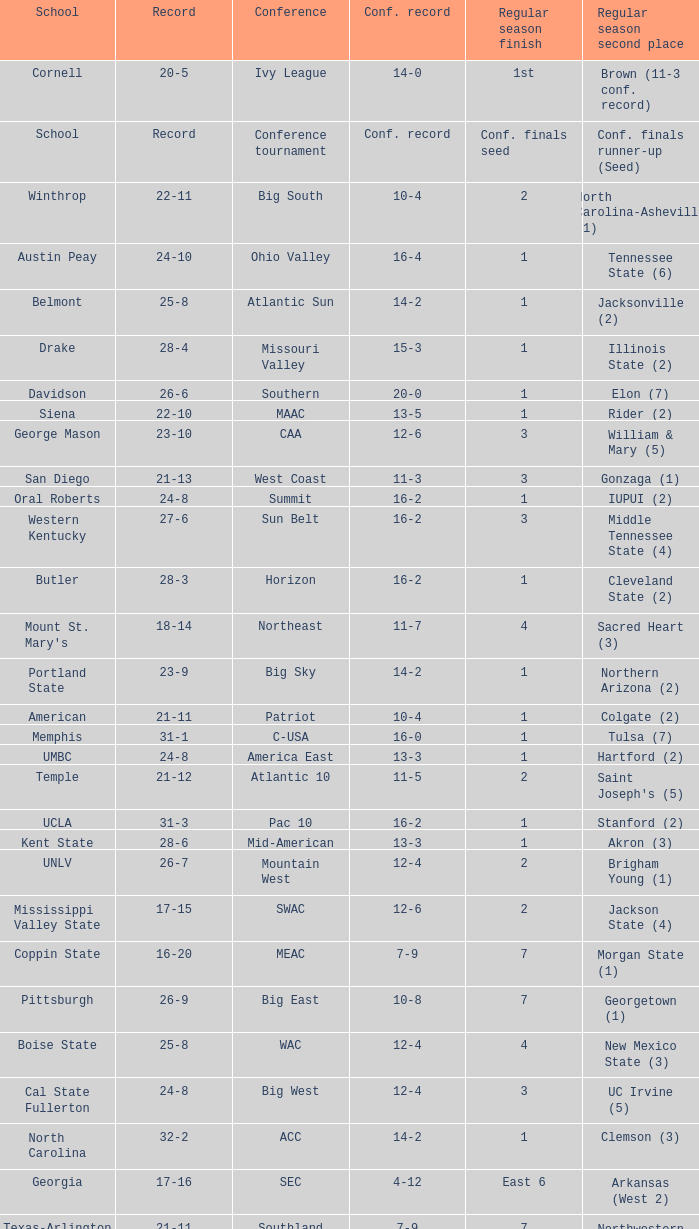Could you help me parse every detail presented in this table? {'header': ['School', 'Record', 'Conference', 'Conf. record', 'Regular season finish', 'Regular season second place'], 'rows': [['Cornell', '20-5', 'Ivy League', '14-0', '1st', 'Brown (11-3 conf. record)'], ['School', 'Record', 'Conference tournament', 'Conf. record', 'Conf. finals seed', 'Conf. finals runner-up (Seed)'], ['Winthrop', '22-11', 'Big South', '10-4', '2', 'North Carolina-Asheville (1)'], ['Austin Peay', '24-10', 'Ohio Valley', '16-4', '1', 'Tennessee State (6)'], ['Belmont', '25-8', 'Atlantic Sun', '14-2', '1', 'Jacksonville (2)'], ['Drake', '28-4', 'Missouri Valley', '15-3', '1', 'Illinois State (2)'], ['Davidson', '26-6', 'Southern', '20-0', '1', 'Elon (7)'], ['Siena', '22-10', 'MAAC', '13-5', '1', 'Rider (2)'], ['George Mason', '23-10', 'CAA', '12-6', '3', 'William & Mary (5)'], ['San Diego', '21-13', 'West Coast', '11-3', '3', 'Gonzaga (1)'], ['Oral Roberts', '24-8', 'Summit', '16-2', '1', 'IUPUI (2)'], ['Western Kentucky', '27-6', 'Sun Belt', '16-2', '3', 'Middle Tennessee State (4)'], ['Butler', '28-3', 'Horizon', '16-2', '1', 'Cleveland State (2)'], ["Mount St. Mary's", '18-14', 'Northeast', '11-7', '4', 'Sacred Heart (3)'], ['Portland State', '23-9', 'Big Sky', '14-2', '1', 'Northern Arizona (2)'], ['American', '21-11', 'Patriot', '10-4', '1', 'Colgate (2)'], ['Memphis', '31-1', 'C-USA', '16-0', '1', 'Tulsa (7)'], ['UMBC', '24-8', 'America East', '13-3', '1', 'Hartford (2)'], ['Temple', '21-12', 'Atlantic 10', '11-5', '2', "Saint Joseph's (5)"], ['UCLA', '31-3', 'Pac 10', '16-2', '1', 'Stanford (2)'], ['Kent State', '28-6', 'Mid-American', '13-3', '1', 'Akron (3)'], ['UNLV', '26-7', 'Mountain West', '12-4', '2', 'Brigham Young (1)'], ['Mississippi Valley State', '17-15', 'SWAC', '12-6', '2', 'Jackson State (4)'], ['Coppin State', '16-20', 'MEAC', '7-9', '7', 'Morgan State (1)'], ['Pittsburgh', '26-9', 'Big East', '10-8', '7', 'Georgetown (1)'], ['Boise State', '25-8', 'WAC', '12-4', '4', 'New Mexico State (3)'], ['Cal State Fullerton', '24-8', 'Big West', '12-4', '3', 'UC Irvine (5)'], ['North Carolina', '32-2', 'ACC', '14-2', '1', 'Clemson (3)'], ['Georgia', '17-16', 'SEC', '4-12', 'East 6', 'Arkansas (West 2)'], ['Texas-Arlington', '21-11', 'Southland', '7-9', '7', 'Northwestern State (5)'], ['Kansas', '31-3', 'Big 12', '13-3', '2', 'Texas (1)']]} Which qualifying schools were in the Patriot conference? American. 